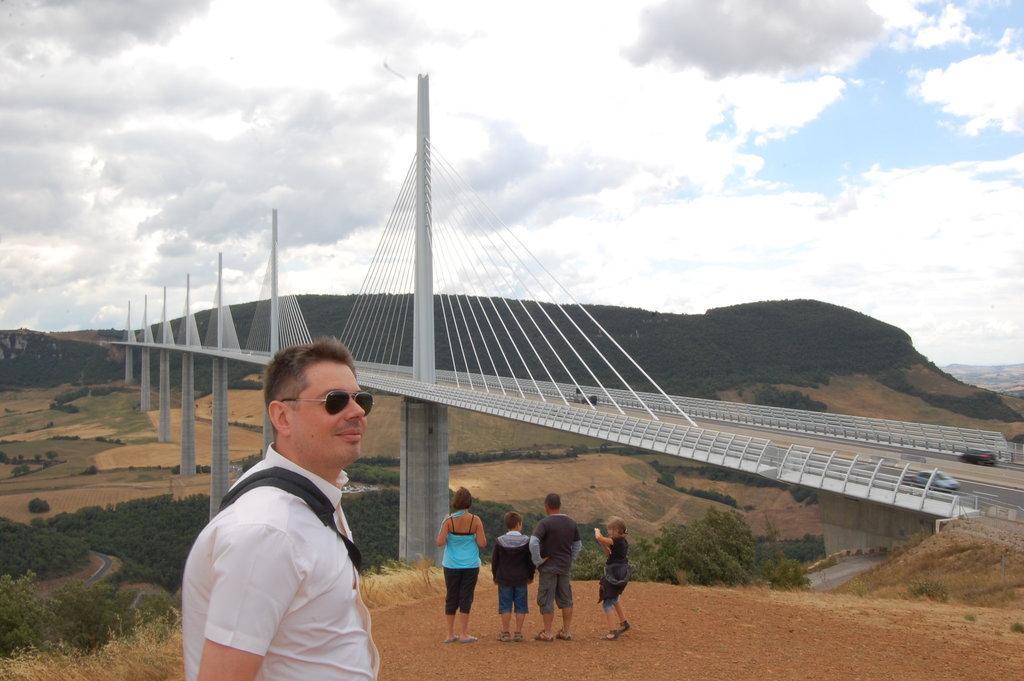Can you describe this image briefly? In this image we can see few persons standing on the ground, a person is wearing a bag, there is a bridge, and there are some mountains, trees, and plants, we can see the sky. 